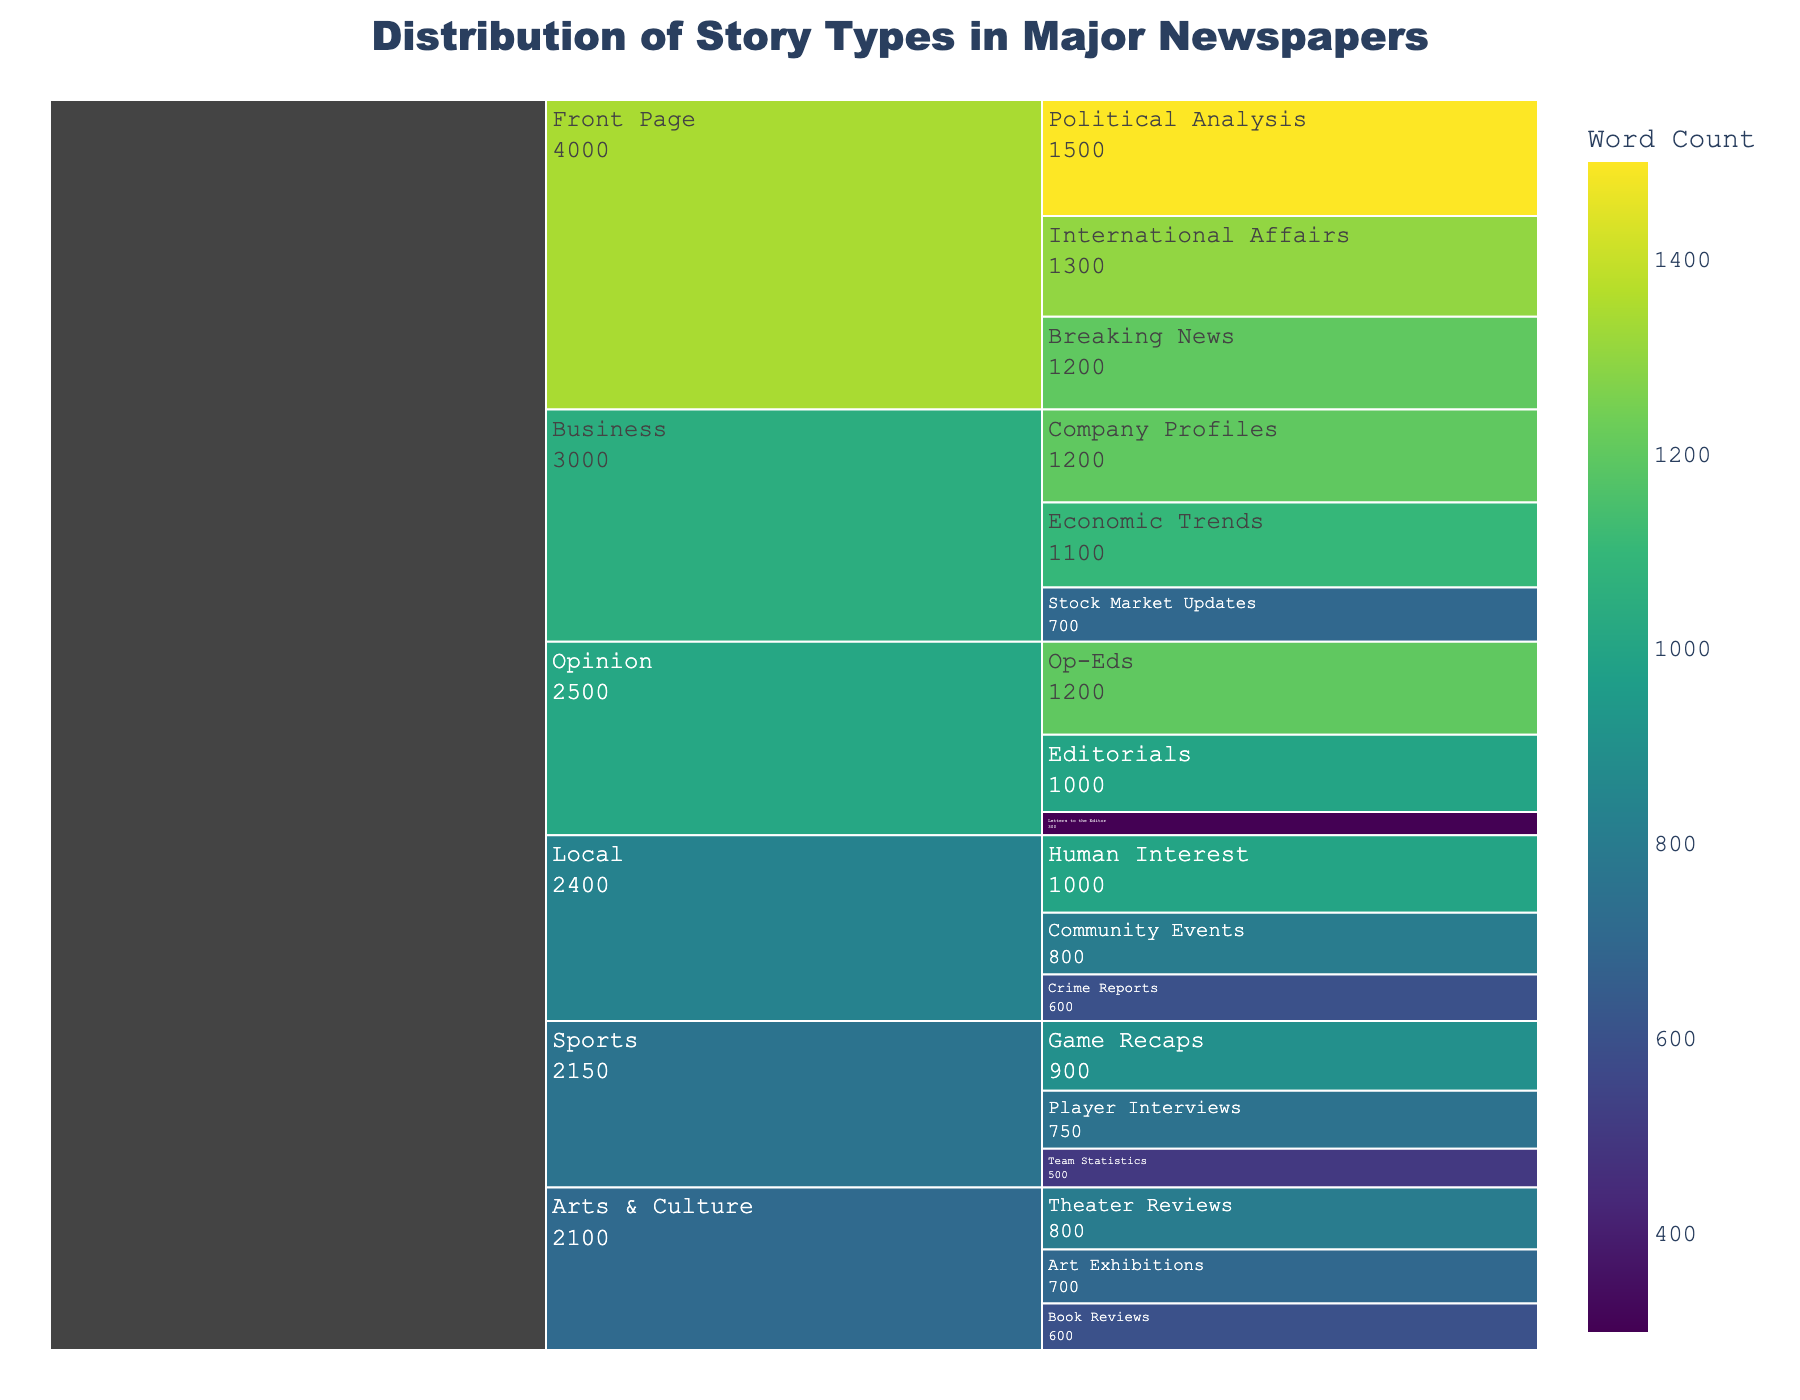What is the total word count for the "Front Page" section? To find the total word count for the "Front Page" section, sum the word counts of "Breaking News," "Political Analysis," and "International Affairs". These are 1200, 1500, and 1300 words respectively. Hence, 1200 + 1500 + 1300 = 4000.
Answer: 4000 How many story types are present in the "Sports" section and what are they? In the "Sports" section, there are three story types: "Game Recaps," "Player Interviews," and "Team Statistics".
Answer: 3: Game Recaps, Player Interviews, Team Statistics Which section has the lowest count story type, and what is its story type? By examining the icicle chart, the "Opinion" section has the story type with the lowest word count, which is "Letters to the Editor" with 300 words.
Answer: Opinion: Letters to the Editor What is the average word count for all the story types in the "Business" section? To find this, sum the word counts for "Stock Market Updates," "Company Profiles," and "Economic Trends" which are 700, 1200, and 1100 respectively. Then divide this sum by the number of story types (3). (700 + 1200 + 1100) / 3 = 1000.
Answer: 1000 Which section has the highest total word count? By summing the word counts in each section, the "Front Page" section has the highest total word count. It has 4000 words (1200 + 1500 + 1300).
Answer: Front Page Compare the word counts of "Human Interest" in the "Local" section and "Editorials" in the "Opinion" section. Which one is higher? The word count of "Human Interest" is 1000, whereas the word count of "Editorials" is also 1000. Therefore, they are equal.
Answer: They are equal Calculate the total word count of the story types under "Arts & Culture." Sum the word counts of "Theater Reviews," "Book Reviews," and "Art Exhibitions". These are 800, 600, and 700 words respectively. Hence, 800 + 600 + 700 = 2100.
Answer: 2100 Compare the word count of the smallest story type and the largest story type in the "Front Page" section. What is the difference in their word counts? The smallest story type in the "Front Page" section (Breaking News) has 1200 words and the largest (Political Analysis) has 1500 words. The difference is 1500 - 1200 = 300.
Answer: 300 Which story type in the "Local" section has the second-highest word count? The word counts for "Community Events," "Crime Reports," and "Human Interest" are 800, 600, and 1000 respectively. The second-highest word count is "Community Events" with 800 words.
Answer: Community Events What is the combined word count for "Op-Eds" and "Book Reviews"? The word count for "Op-Eds" is 1200 and for "Book Reviews" is 600. So the combined count is 1200 + 600 = 1800.
Answer: 1800 